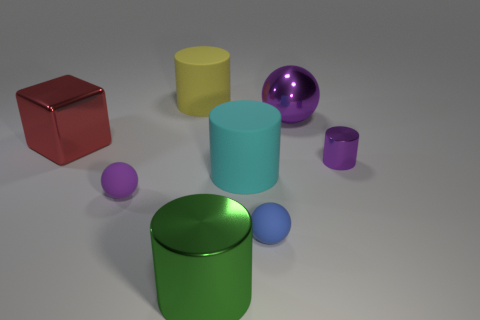Add 1 small blue blocks. How many objects exist? 9 Subtract all cubes. How many objects are left? 7 Add 8 large purple metal balls. How many large purple metal balls exist? 9 Subtract 0 blue cylinders. How many objects are left? 8 Subtract all green metallic cylinders. Subtract all large metal cylinders. How many objects are left? 6 Add 3 big blocks. How many big blocks are left? 4 